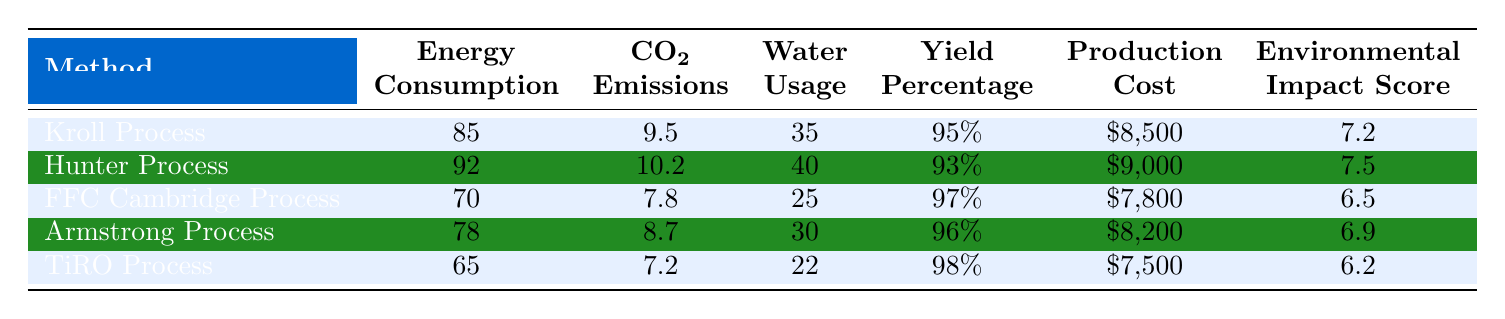What is the energy consumption of the TiRO Process? The table shows that the TiRO Process has an energy consumption value listed as 65.
Answer: 65 Which production method has the highest CO2 emissions? By comparing the CO2 emissions values in the table, the Hunter Process has the highest emissions at 10.2.
Answer: Hunter Process What is the yield percentage of the FFC Cambridge Process? The yield percentage for the FFC Cambridge Process is indicated in the table as 97%.
Answer: 97% What is the average production cost of all methods? To find the average, sum the production costs: (8500 + 9000 + 7800 + 8200 + 7500) = 40000. Then divide by the number of methods (5): 40000 / 5 = 8000.
Answer: 8000 Is the water usage in the Kroll Process higher than that in the TiRO Process? The table shows the Kroll Process uses 35 units of water, while the TiRO Process uses 22 units; since 35 > 22, this statement is true.
Answer: Yes Which process has the lowest environmental impact score? The table lists the environmental impact scores, and the lowest score is 6.2, which corresponds to the TiRO Process.
Answer: TiRO Process How much more energy does the Hunter Process consume compared to the TiRO Process? The energy consumption of the Hunter Process is 92, and for the TiRO Process, it is 65. The difference is 92 - 65 = 27.
Answer: 27 Can we say that the Armstrong Process is more efficient than the Kroll Process based on yield percentage? The Armstrong Process has a yield of 96% compared to Kroll's 95%. Since 96 > 95, Armstrong is indeed more efficient.
Answer: Yes What is the total water usage across all production methods? To find the total water usage, sum the individual values: 35 + 40 + 25 + 30 + 22 = 152.
Answer: 152 Which production method has the lowest energy consumption? Referring to the energy consumption values, the TiRO Process has the lowest at 65.
Answer: TiRO Process 